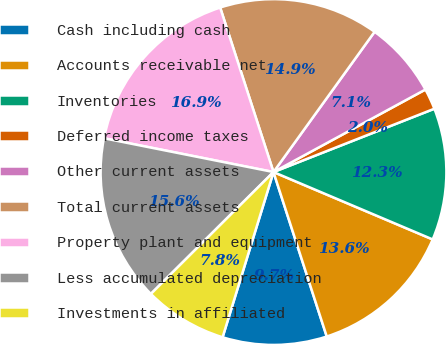<chart> <loc_0><loc_0><loc_500><loc_500><pie_chart><fcel>Cash including cash<fcel>Accounts receivable net<fcel>Inventories<fcel>Deferred income taxes<fcel>Other current assets<fcel>Total current assets<fcel>Property plant and equipment<fcel>Less accumulated depreciation<fcel>Investments in affiliated<nl><fcel>9.74%<fcel>13.64%<fcel>12.34%<fcel>1.95%<fcel>7.14%<fcel>14.93%<fcel>16.88%<fcel>15.58%<fcel>7.79%<nl></chart> 